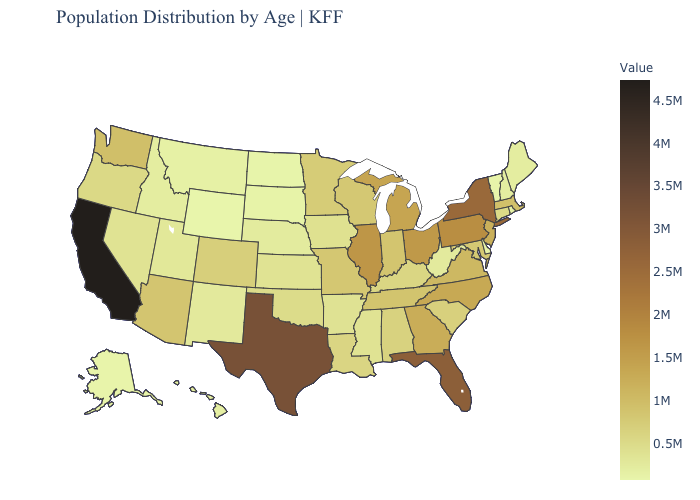Does Wyoming have the lowest value in the West?
Write a very short answer. Yes. Among the states that border New Hampshire , which have the highest value?
Write a very short answer. Massachusetts. Which states hav the highest value in the South?
Give a very brief answer. Texas. Among the states that border Minnesota , does South Dakota have the lowest value?
Keep it brief. No. 